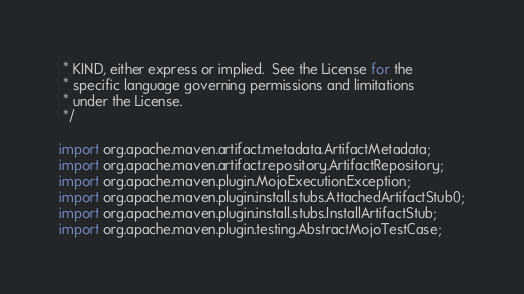<code> <loc_0><loc_0><loc_500><loc_500><_Java_> * KIND, either express or implied.  See the License for the
 * specific language governing permissions and limitations
 * under the License.
 */

import org.apache.maven.artifact.metadata.ArtifactMetadata;
import org.apache.maven.artifact.repository.ArtifactRepository;
import org.apache.maven.plugin.MojoExecutionException;
import org.apache.maven.plugin.install.stubs.AttachedArtifactStub0;
import org.apache.maven.plugin.install.stubs.InstallArtifactStub;
import org.apache.maven.plugin.testing.AbstractMojoTestCase;</code> 